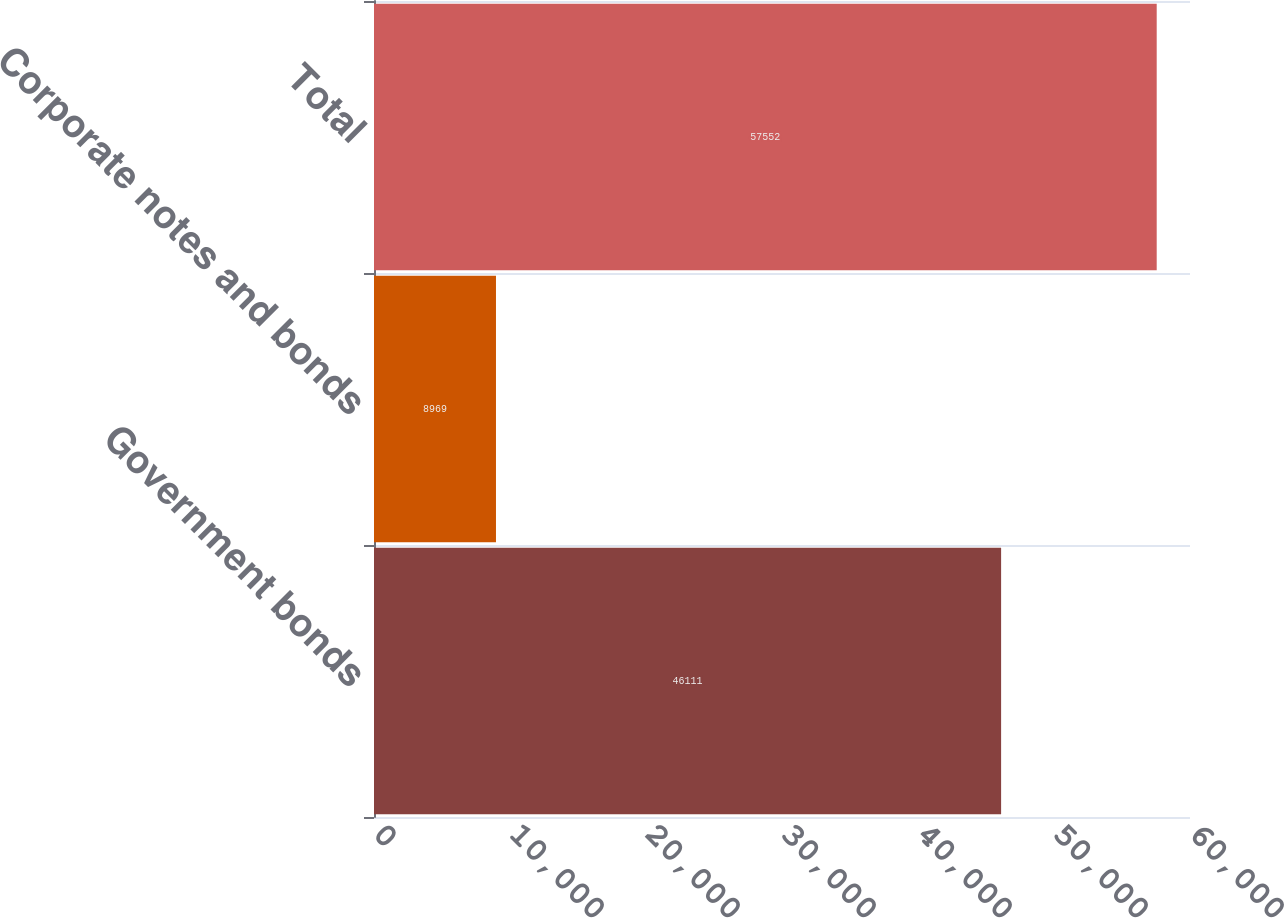Convert chart. <chart><loc_0><loc_0><loc_500><loc_500><bar_chart><fcel>Government bonds<fcel>Corporate notes and bonds<fcel>Total<nl><fcel>46111<fcel>8969<fcel>57552<nl></chart> 